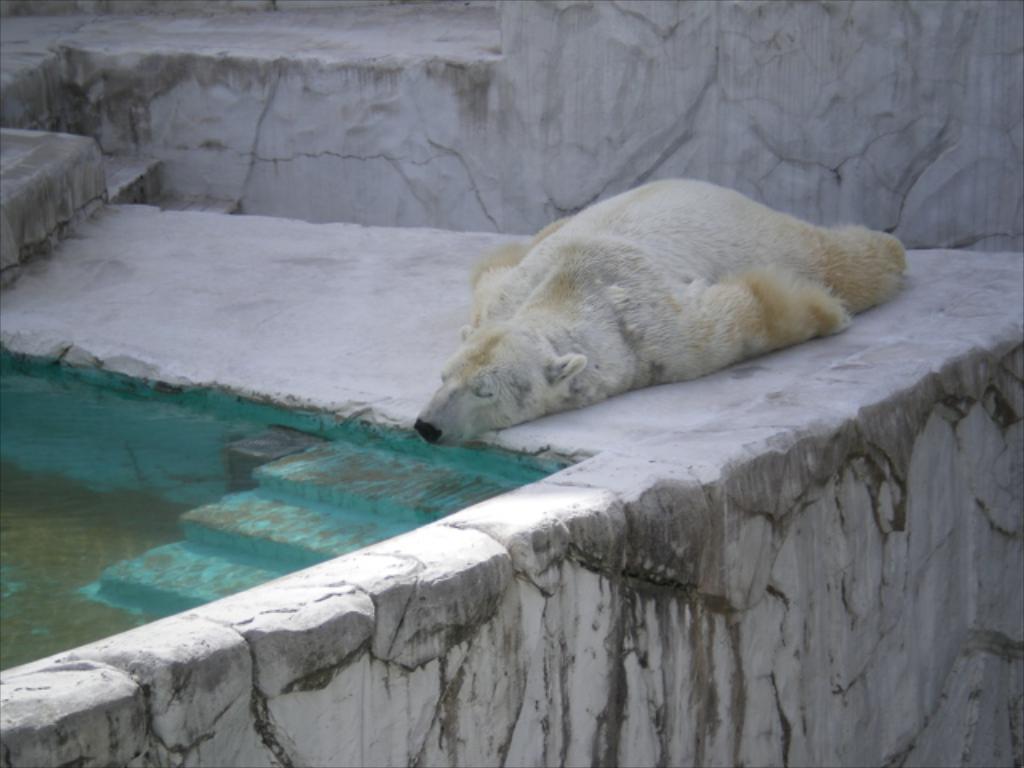In one or two sentences, can you explain what this image depicts? In the center of the image there is a polar bear sleeping on the floor. In the background we can see wall. On the left side of the image there is water. 